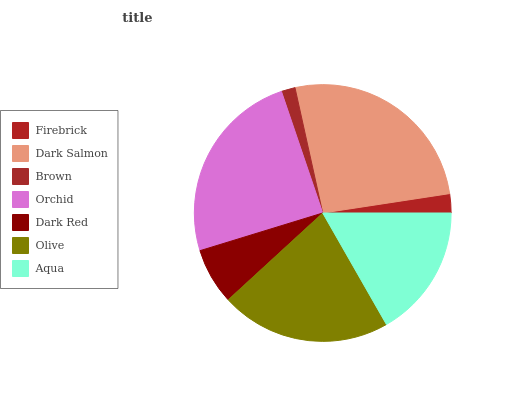Is Brown the minimum?
Answer yes or no. Yes. Is Dark Salmon the maximum?
Answer yes or no. Yes. Is Dark Salmon the minimum?
Answer yes or no. No. Is Brown the maximum?
Answer yes or no. No. Is Dark Salmon greater than Brown?
Answer yes or no. Yes. Is Brown less than Dark Salmon?
Answer yes or no. Yes. Is Brown greater than Dark Salmon?
Answer yes or no. No. Is Dark Salmon less than Brown?
Answer yes or no. No. Is Aqua the high median?
Answer yes or no. Yes. Is Aqua the low median?
Answer yes or no. Yes. Is Dark Salmon the high median?
Answer yes or no. No. Is Orchid the low median?
Answer yes or no. No. 